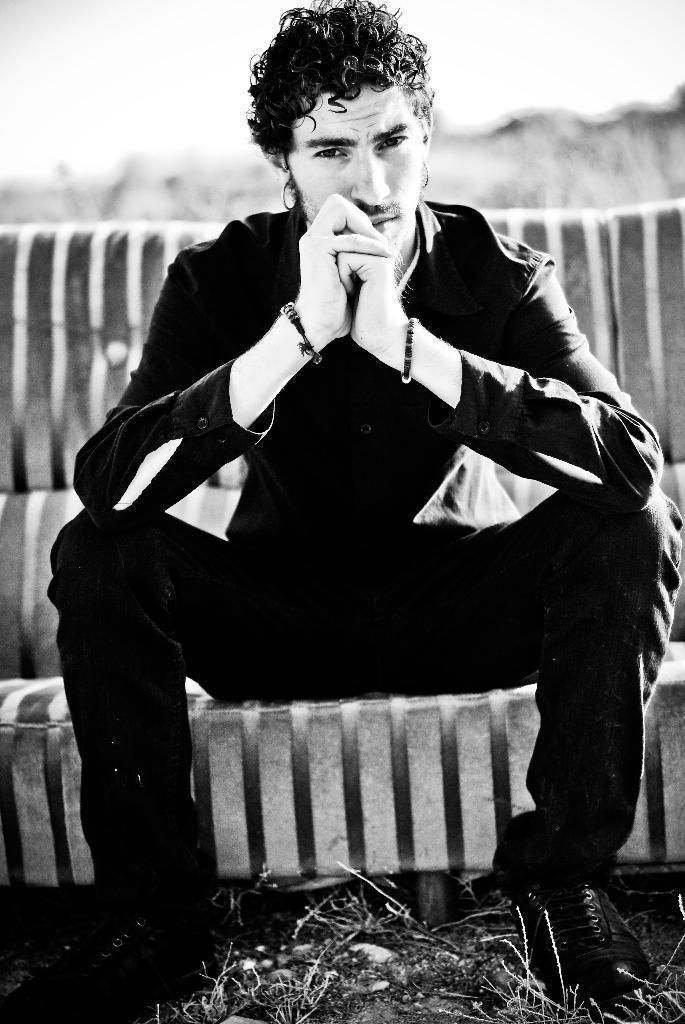Can you describe this image briefly? It is the black and white image in which we can see that there is a man who is sitting on the sofa. 